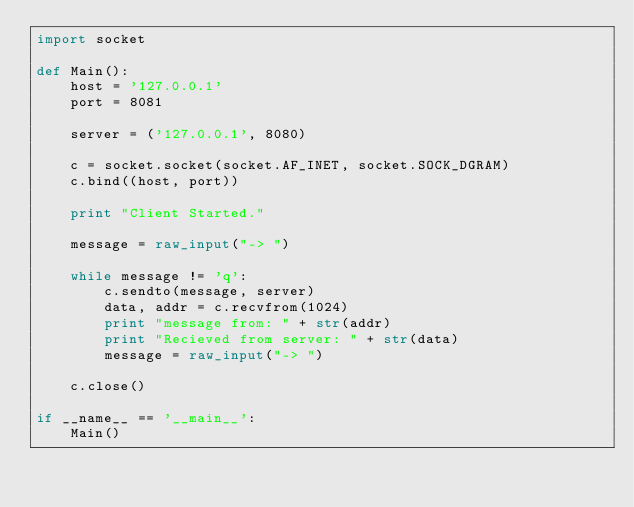<code> <loc_0><loc_0><loc_500><loc_500><_Python_>import socket

def Main():
    host = '127.0.0.1'
    port = 8081

    server = ('127.0.0.1', 8080)

    c = socket.socket(socket.AF_INET, socket.SOCK_DGRAM)
    c.bind((host, port))

    print "Client Started."

    message = raw_input("-> ")

    while message != 'q':
        c.sendto(message, server)
        data, addr = c.recvfrom(1024)
        print "message from: " + str(addr)
        print "Recieved from server: " + str(data)
        message = raw_input("-> ")
        
    c.close()

if __name__ == '__main__':
    Main()</code> 